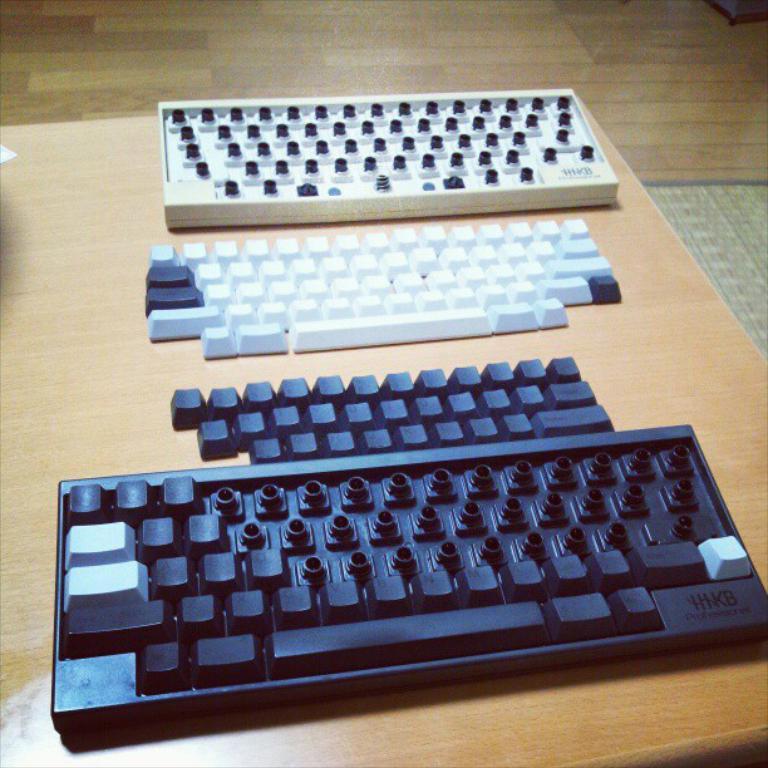What are the letters on the bottom right?
Offer a very short reply. Hikb. 